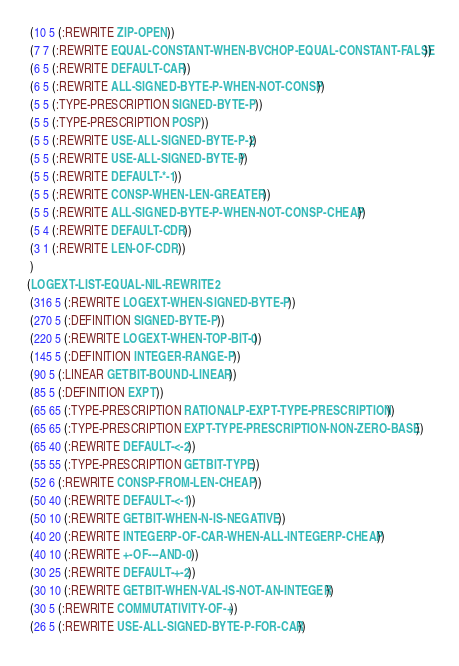<code> <loc_0><loc_0><loc_500><loc_500><_Lisp_> (10 5 (:REWRITE ZIP-OPEN))
 (7 7 (:REWRITE EQUAL-CONSTANT-WHEN-BVCHOP-EQUAL-CONSTANT-FALSE))
 (6 5 (:REWRITE DEFAULT-CAR))
 (6 5 (:REWRITE ALL-SIGNED-BYTE-P-WHEN-NOT-CONSP))
 (5 5 (:TYPE-PRESCRIPTION SIGNED-BYTE-P))
 (5 5 (:TYPE-PRESCRIPTION POSP))
 (5 5 (:REWRITE USE-ALL-SIGNED-BYTE-P-2))
 (5 5 (:REWRITE USE-ALL-SIGNED-BYTE-P))
 (5 5 (:REWRITE DEFAULT-*-1))
 (5 5 (:REWRITE CONSP-WHEN-LEN-GREATER))
 (5 5 (:REWRITE ALL-SIGNED-BYTE-P-WHEN-NOT-CONSP-CHEAP))
 (5 4 (:REWRITE DEFAULT-CDR))
 (3 1 (:REWRITE LEN-OF-CDR))
 )
(LOGEXT-LIST-EQUAL-NIL-REWRITE2
 (316 5 (:REWRITE LOGEXT-WHEN-SIGNED-BYTE-P))
 (270 5 (:DEFINITION SIGNED-BYTE-P))
 (220 5 (:REWRITE LOGEXT-WHEN-TOP-BIT-0))
 (145 5 (:DEFINITION INTEGER-RANGE-P))
 (90 5 (:LINEAR GETBIT-BOUND-LINEAR))
 (85 5 (:DEFINITION EXPT))
 (65 65 (:TYPE-PRESCRIPTION RATIONALP-EXPT-TYPE-PRESCRIPTION))
 (65 65 (:TYPE-PRESCRIPTION EXPT-TYPE-PRESCRIPTION-NON-ZERO-BASE))
 (65 40 (:REWRITE DEFAULT-<-2))
 (55 55 (:TYPE-PRESCRIPTION GETBIT-TYPE))
 (52 6 (:REWRITE CONSP-FROM-LEN-CHEAP))
 (50 40 (:REWRITE DEFAULT-<-1))
 (50 10 (:REWRITE GETBIT-WHEN-N-IS-NEGATIVE))
 (40 20 (:REWRITE INTEGERP-OF-CAR-WHEN-ALL-INTEGERP-CHEAP))
 (40 10 (:REWRITE +-OF---AND-0))
 (30 25 (:REWRITE DEFAULT-+-2))
 (30 10 (:REWRITE GETBIT-WHEN-VAL-IS-NOT-AN-INTEGER))
 (30 5 (:REWRITE COMMUTATIVITY-OF-+))
 (26 5 (:REWRITE USE-ALL-SIGNED-BYTE-P-FOR-CAR))</code> 